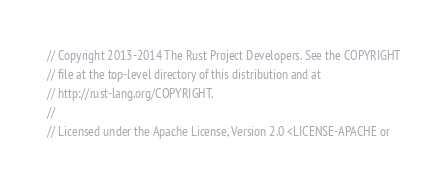Convert code to text. <code><loc_0><loc_0><loc_500><loc_500><_Rust_>// Copyright 2013-2014 The Rust Project Developers. See the COPYRIGHT
// file at the top-level directory of this distribution and at
// http://rust-lang.org/COPYRIGHT.
//
// Licensed under the Apache License, Version 2.0 <LICENSE-APACHE or</code> 